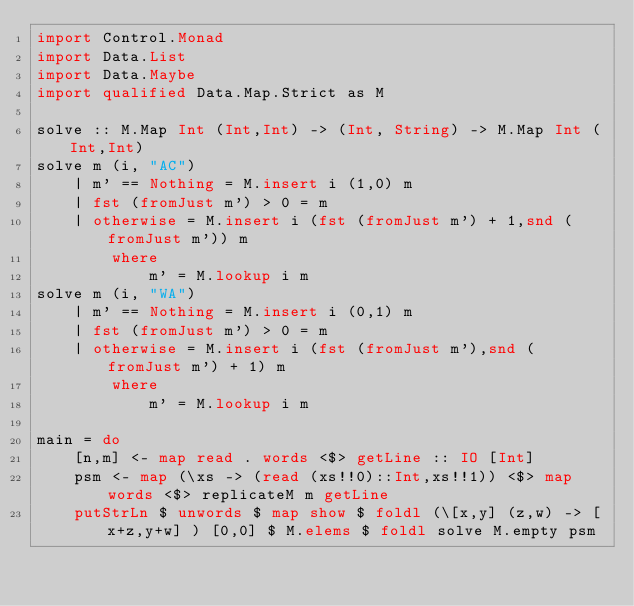Convert code to text. <code><loc_0><loc_0><loc_500><loc_500><_Haskell_>import Control.Monad
import Data.List
import Data.Maybe
import qualified Data.Map.Strict as M

solve :: M.Map Int (Int,Int) -> (Int, String) -> M.Map Int (Int,Int)
solve m (i, "AC")
    | m' == Nothing = M.insert i (1,0) m
    | fst (fromJust m') > 0 = m
    | otherwise = M.insert i (fst (fromJust m') + 1,snd (fromJust m')) m
        where
            m' = M.lookup i m
solve m (i, "WA")
    | m' == Nothing = M.insert i (0,1) m
    | fst (fromJust m') > 0 = m
    | otherwise = M.insert i (fst (fromJust m'),snd (fromJust m') + 1) m
        where
            m' = M.lookup i m

main = do
    [n,m] <- map read . words <$> getLine :: IO [Int]
    psm <- map (\xs -> (read (xs!!0)::Int,xs!!1)) <$> map words <$> replicateM m getLine
    putStrLn $ unwords $ map show $ foldl (\[x,y] (z,w) -> [x+z,y+w] ) [0,0] $ M.elems $ foldl solve M.empty psm
    
</code> 